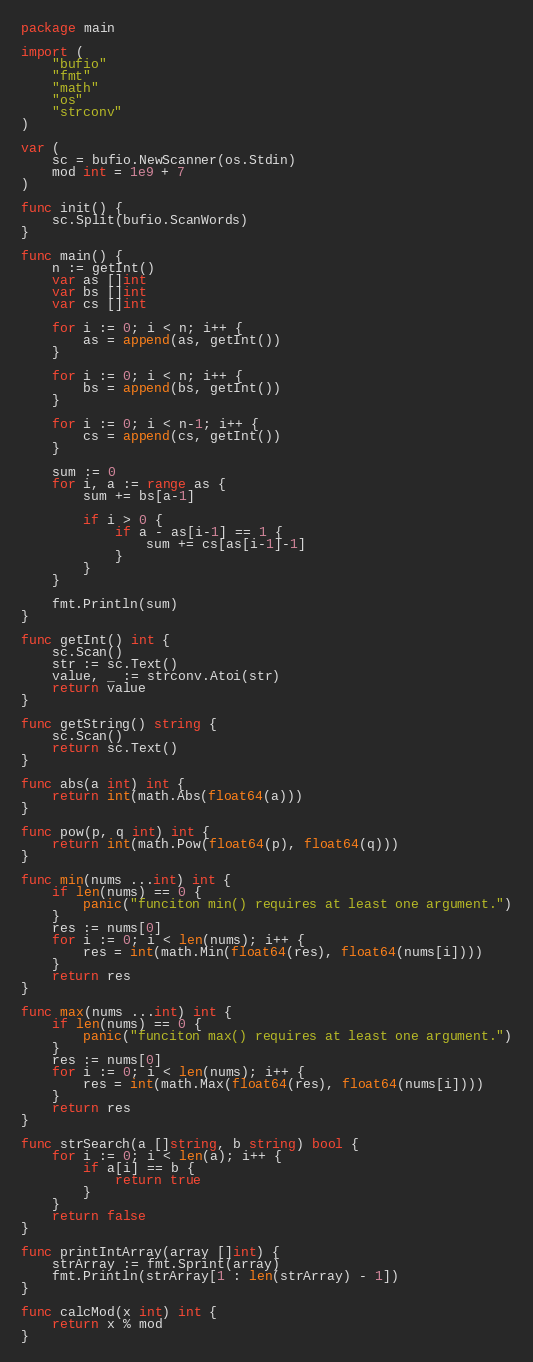Convert code to text. <code><loc_0><loc_0><loc_500><loc_500><_Go_>package main

import (
	"bufio"
	"fmt"
	"math"
	"os"
	"strconv"
)

var (
	sc = bufio.NewScanner(os.Stdin)
	mod int = 1e9 + 7
)

func init() {
	sc.Split(bufio.ScanWords)
}

func main() {
	n := getInt()
	var as []int
	var bs []int
	var cs []int

	for i := 0; i < n; i++ {
		as = append(as, getInt())
	}

	for i := 0; i < n; i++ {
		bs = append(bs, getInt())
	}

	for i := 0; i < n-1; i++ {
		cs = append(cs, getInt())
	}

	sum := 0
	for i, a := range as {
		sum += bs[a-1]

		if i > 0 {
			if a - as[i-1] == 1 {
				sum += cs[as[i-1]-1]
			}
		}
	}

	fmt.Println(sum)
}

func getInt() int {
	sc.Scan()
	str := sc.Text()
	value, _ := strconv.Atoi(str)
	return value
}

func getString() string {
	sc.Scan()
	return sc.Text()
}

func abs(a int) int {
	return int(math.Abs(float64(a)))
}

func pow(p, q int) int {
	return int(math.Pow(float64(p), float64(q)))
}

func min(nums ...int) int {
	if len(nums) == 0 {
		panic("funciton min() requires at least one argument.")
	}
	res := nums[0]
	for i := 0; i < len(nums); i++ {
		res = int(math.Min(float64(res), float64(nums[i])))
	}
	return res
}

func max(nums ...int) int {
	if len(nums) == 0 {
		panic("funciton max() requires at least one argument.")
	}
	res := nums[0]
	for i := 0; i < len(nums); i++ {
		res = int(math.Max(float64(res), float64(nums[i])))
	}
	return res
}

func strSearch(a []string, b string) bool {
	for i := 0; i < len(a); i++ {
		if a[i] == b {
			return true
		}
	}
	return false
}

func printIntArray(array []int) {
	strArray := fmt.Sprint(array)
	fmt.Println(strArray[1 : len(strArray) - 1])
}

func calcMod(x int) int {
	return x % mod
}
</code> 